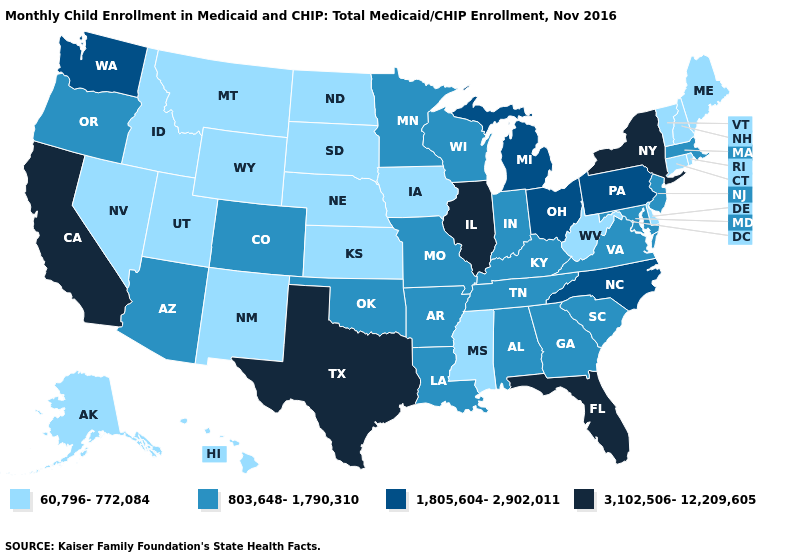Among the states that border South Dakota , which have the lowest value?
Answer briefly. Iowa, Montana, Nebraska, North Dakota, Wyoming. What is the lowest value in states that border Kentucky?
Answer briefly. 60,796-772,084. Name the states that have a value in the range 3,102,506-12,209,605?
Write a very short answer. California, Florida, Illinois, New York, Texas. Which states have the lowest value in the Northeast?
Keep it brief. Connecticut, Maine, New Hampshire, Rhode Island, Vermont. Among the states that border Pennsylvania , does West Virginia have the lowest value?
Answer briefly. Yes. Among the states that border Oklahoma , does New Mexico have the lowest value?
Quick response, please. Yes. Name the states that have a value in the range 60,796-772,084?
Answer briefly. Alaska, Connecticut, Delaware, Hawaii, Idaho, Iowa, Kansas, Maine, Mississippi, Montana, Nebraska, Nevada, New Hampshire, New Mexico, North Dakota, Rhode Island, South Dakota, Utah, Vermont, West Virginia, Wyoming. What is the highest value in the USA?
Keep it brief. 3,102,506-12,209,605. Name the states that have a value in the range 60,796-772,084?
Answer briefly. Alaska, Connecticut, Delaware, Hawaii, Idaho, Iowa, Kansas, Maine, Mississippi, Montana, Nebraska, Nevada, New Hampshire, New Mexico, North Dakota, Rhode Island, South Dakota, Utah, Vermont, West Virginia, Wyoming. What is the highest value in states that border Massachusetts?
Answer briefly. 3,102,506-12,209,605. Which states have the highest value in the USA?
Concise answer only. California, Florida, Illinois, New York, Texas. Name the states that have a value in the range 1,805,604-2,902,011?
Concise answer only. Michigan, North Carolina, Ohio, Pennsylvania, Washington. Does Texas have the highest value in the USA?
Concise answer only. Yes. What is the value of Delaware?
Concise answer only. 60,796-772,084. Does California have the lowest value in the West?
Write a very short answer. No. 